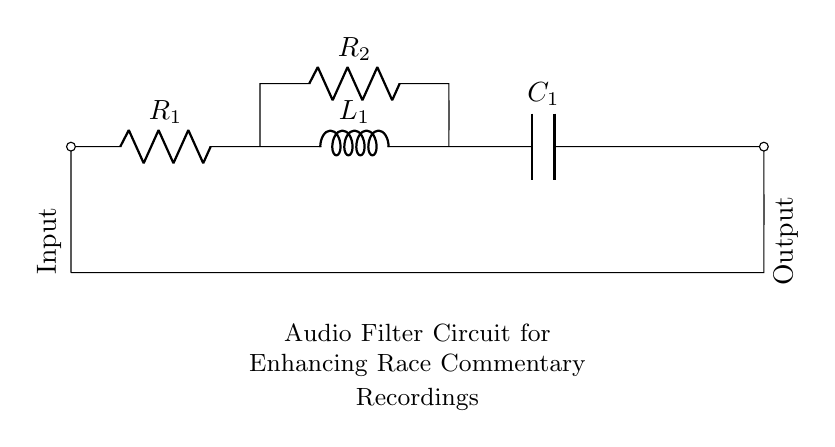What is the first component in the circuit? The first component in the circuit is the resistor labeled R1. It is located at the leftmost part of the diagram.
Answer: R1 How many components are in series? To determine this, we can count the components that are connected end-to-end without any branching. The series components are R1, L1, and C1, totaling three.
Answer: 3 What does the capacitor do in this circuit? The capacitor, noted as C1 in the circuit, is used for filtering, allowing specific frequencies to pass while blocking others, contributing to enhancing the audio quality.
Answer: Filtering What is the role of the inductor in this circuit? The inductor replaces a certain frequency band and works together with the capacitor to form a filter. It can store energy in its magnetic field, contributing to the circuit's overall response to audio signals.
Answer: Energy storage What is the function of the resistors R2 in the circuit? Resistor R2 is connected in parallel with L1 and C1, helping to set the overall impedance and adjusting the frequency response of the filter by controlling the flow of current.
Answer: Impedance control Which component is at the output of the circuit? The output is connected to the rightmost part of the circuit, where the line is drawn to signify the output, but no specific output component is denoted other than where the filtered signal can be taken from.
Answer: Output (no component) What kind of filter does this arrangement represent? This arrangement typically represents a resonant or band-pass filter, as it selectively allows signals within a certain frequency range while attenuating others.
Answer: Band-pass filter 